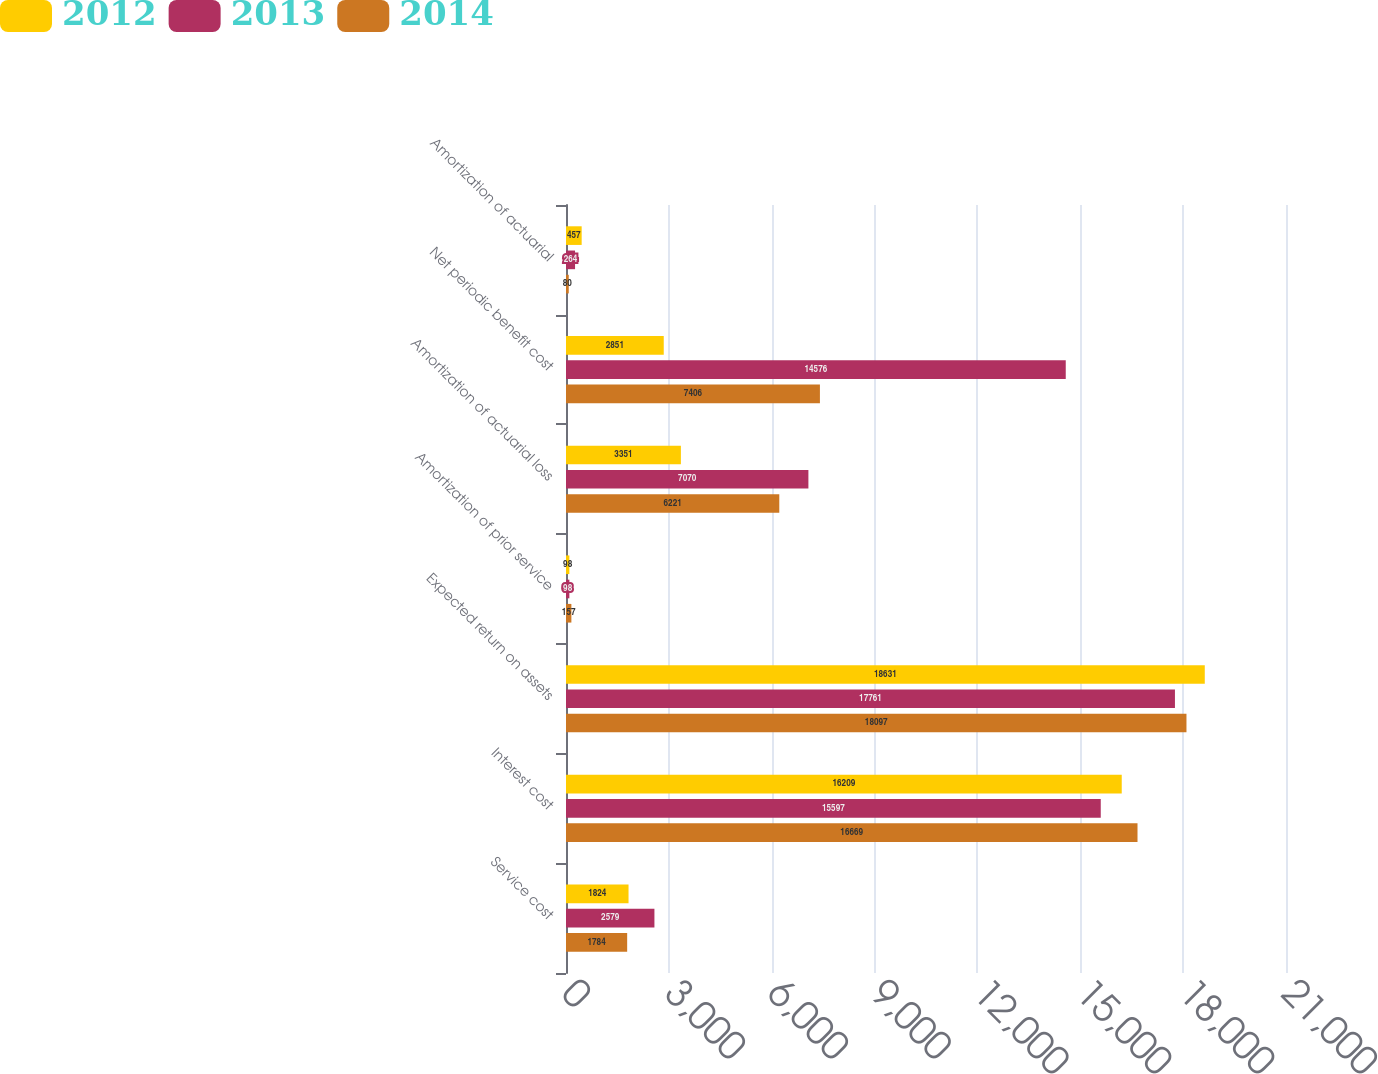<chart> <loc_0><loc_0><loc_500><loc_500><stacked_bar_chart><ecel><fcel>Service cost<fcel>Interest cost<fcel>Expected return on assets<fcel>Amortization of prior service<fcel>Amortization of actuarial loss<fcel>Net periodic benefit cost<fcel>Amortization of actuarial<nl><fcel>2012<fcel>1824<fcel>16209<fcel>18631<fcel>98<fcel>3351<fcel>2851<fcel>457<nl><fcel>2013<fcel>2579<fcel>15597<fcel>17761<fcel>98<fcel>7070<fcel>14576<fcel>264<nl><fcel>2014<fcel>1784<fcel>16669<fcel>18097<fcel>157<fcel>6221<fcel>7406<fcel>80<nl></chart> 